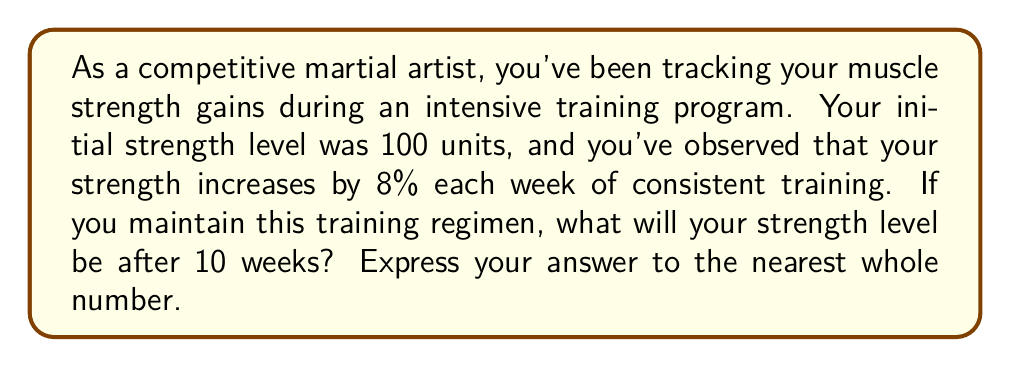What is the answer to this math problem? Let's approach this step-by-step:

1) Initial strength: 100 units
2) Weekly increase: 8% = 0.08
3) Time period: 10 weeks

We can model this scenario using exponential growth:

$$ S = S_0 \cdot (1 + r)^t $$

Where:
$S$ = Final strength
$S_0$ = Initial strength (100 units)
$r$ = Growth rate (0.08)
$t$ = Time period (10 weeks)

Plugging in our values:

$$ S = 100 \cdot (1 + 0.08)^{10} $$

Now, let's calculate:

$$ S = 100 \cdot (1.08)^{10} $$
$$ S = 100 \cdot 2.1589 $$
$$ S = 215.89 $$

Rounding to the nearest whole number:

$$ S \approx 216 $$
Answer: 216 units 